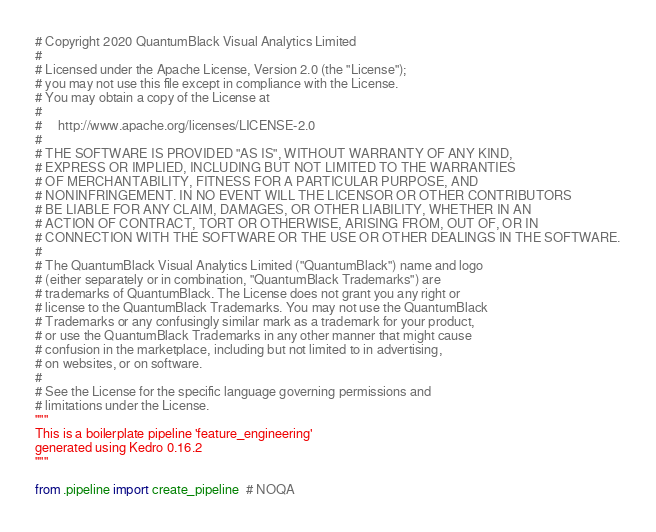Convert code to text. <code><loc_0><loc_0><loc_500><loc_500><_Python_># Copyright 2020 QuantumBlack Visual Analytics Limited
#
# Licensed under the Apache License, Version 2.0 (the "License");
# you may not use this file except in compliance with the License.
# You may obtain a copy of the License at
#
#     http://www.apache.org/licenses/LICENSE-2.0
#
# THE SOFTWARE IS PROVIDED "AS IS", WITHOUT WARRANTY OF ANY KIND,
# EXPRESS OR IMPLIED, INCLUDING BUT NOT LIMITED TO THE WARRANTIES
# OF MERCHANTABILITY, FITNESS FOR A PARTICULAR PURPOSE, AND
# NONINFRINGEMENT. IN NO EVENT WILL THE LICENSOR OR OTHER CONTRIBUTORS
# BE LIABLE FOR ANY CLAIM, DAMAGES, OR OTHER LIABILITY, WHETHER IN AN
# ACTION OF CONTRACT, TORT OR OTHERWISE, ARISING FROM, OUT OF, OR IN
# CONNECTION WITH THE SOFTWARE OR THE USE OR OTHER DEALINGS IN THE SOFTWARE.
#
# The QuantumBlack Visual Analytics Limited ("QuantumBlack") name and logo
# (either separately or in combination, "QuantumBlack Trademarks") are
# trademarks of QuantumBlack. The License does not grant you any right or
# license to the QuantumBlack Trademarks. You may not use the QuantumBlack
# Trademarks or any confusingly similar mark as a trademark for your product,
# or use the QuantumBlack Trademarks in any other manner that might cause
# confusion in the marketplace, including but not limited to in advertising,
# on websites, or on software.
#
# See the License for the specific language governing permissions and
# limitations under the License.
"""
This is a boilerplate pipeline 'feature_engineering'
generated using Kedro 0.16.2
"""

from .pipeline import create_pipeline  # NOQA
</code> 